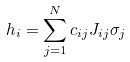Convert formula to latex. <formula><loc_0><loc_0><loc_500><loc_500>h _ { i } = \sum _ { j = 1 } ^ { N } c _ { i j } J _ { i j } \sigma _ { j }</formula> 